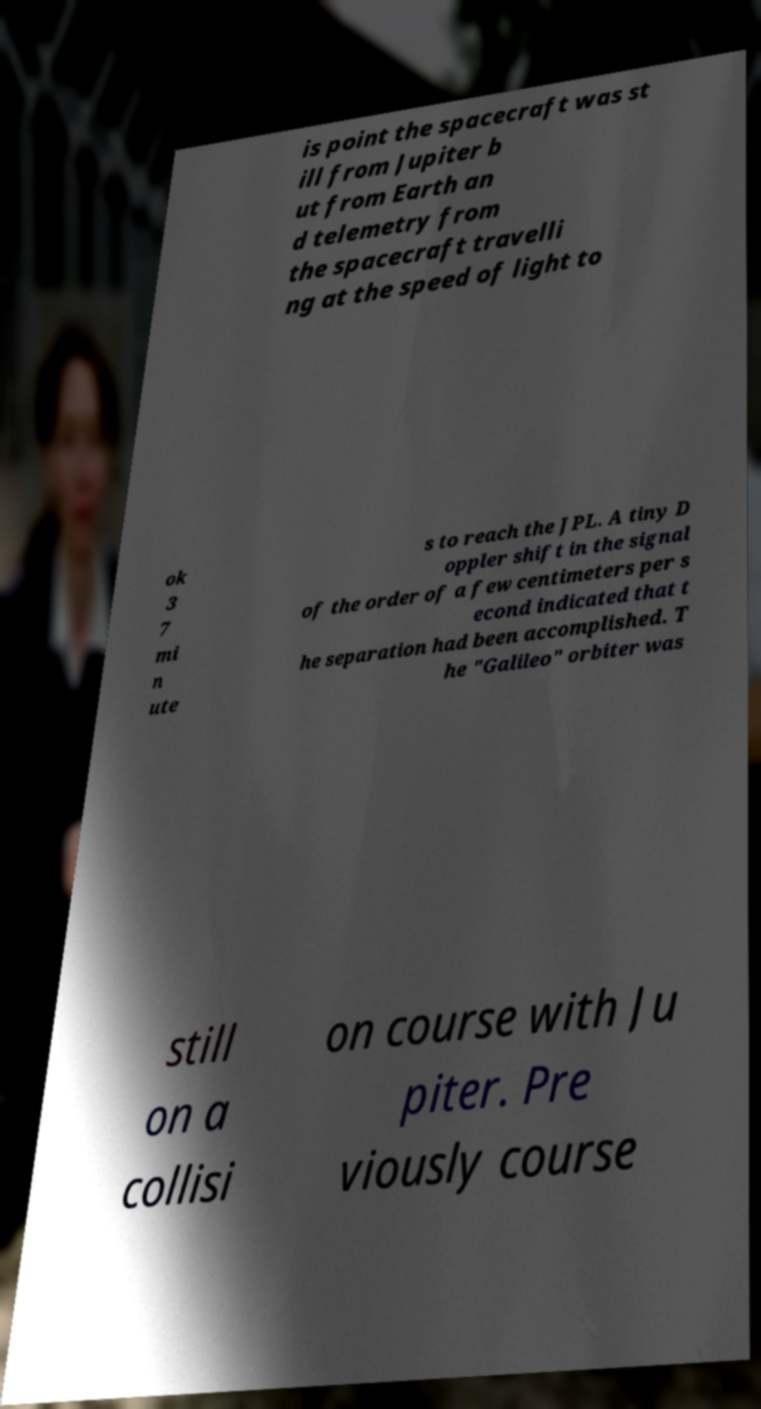For documentation purposes, I need the text within this image transcribed. Could you provide that? is point the spacecraft was st ill from Jupiter b ut from Earth an d telemetry from the spacecraft travelli ng at the speed of light to ok 3 7 mi n ute s to reach the JPL. A tiny D oppler shift in the signal of the order of a few centimeters per s econd indicated that t he separation had been accomplished. T he "Galileo" orbiter was still on a collisi on course with Ju piter. Pre viously course 